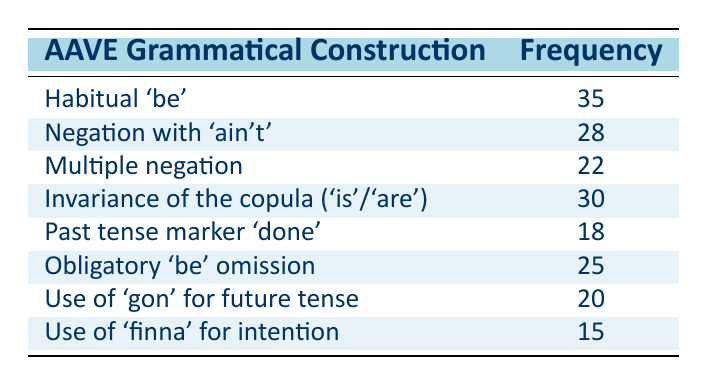What is the frequency of "Habitual 'be'"? The frequency of "Habitual 'be'" is directly listed in the table under the corresponding construction, showing a value of 35.
Answer: 35 What is the frequency of "Negation with 'ain't'"? The table states that the frequency of "Negation with 'ain't'" is 28.
Answer: 28 Which AAVE grammatical construction has the lowest frequency? Looking at the table's frequency values, "Use of 'finna' for intention" has the lowest frequency at 15.
Answer: Use of 'finna' for intention What is the total frequency of the top three AAVE grammatical constructions? The top three constructions are "Habitual 'be'" (35), "Invariance of the copula" (30), and "Negation with 'ain't'" (28). Summing these gives a total frequency of 35 + 30 + 28 = 93.
Answer: 93 Is the frequency of "Obligatory 'be' omission" higher than that of "Multiple negation"? Comparing the frequencies in the table, "Obligatory 'be' omission" has a frequency of 25, while "Multiple negation" has 22. Therefore, it is indeed higher.
Answer: Yes What is the difference in frequency between "Invariance of the copula" and "Past tense marker 'done'"? The frequency for "Invariance of the copula" is 30, and for "Past tense marker 'done'", it is 18. The difference is calculated as 30 - 18 = 12.
Answer: 12 What is the average frequency of the seven constructions listed in the table? To find the average, first sum the frequencies: 35 + 28 + 22 + 30 + 18 + 25 + 20 + 15 = 173. There are 8 constructions, so the average frequency is 173 / 8 = 21.625.
Answer: 21.625 Does "Use of 'gon' for future tense" have a higher frequency than "Use of 'finna' for intention"? "Use of 'gon' for future tense" has a frequency of 20, while "Use of 'finna' for intention" has a frequency of 15. Thus, the statement is true.
Answer: Yes Which construction has a frequency that is 5 less than "Negation with 'ain't'"? "Negation with 'ain't'" has a frequency of 28. A frequency that is 5 less would be 28 - 5 = 23. The closest construction with a frequency of 22 is "Multiple negation", which is indeed 5 less.
Answer: Multiple negation 